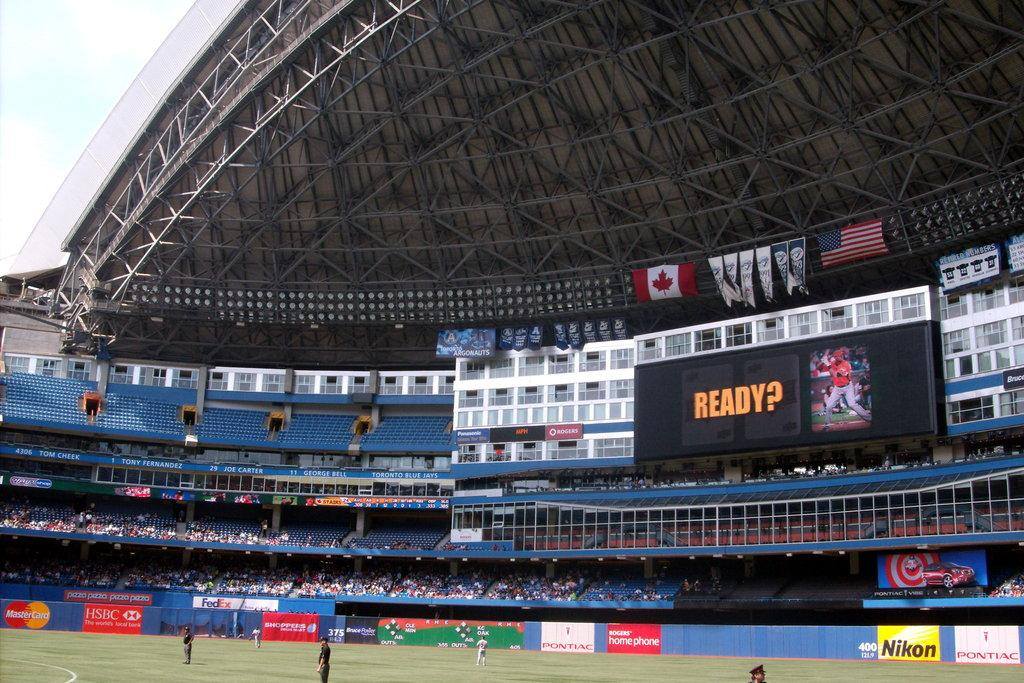<image>
Share a concise interpretation of the image provided. A scoreboard above the field reads "ready?" with the picture of a player next to it 